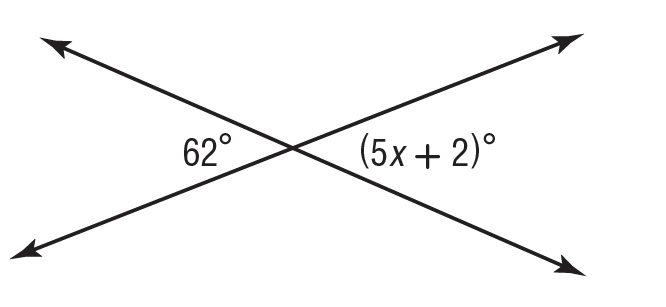Answer the mathemtical geometry problem and directly provide the correct option letter.
Question: What is the value of x in the figure?
Choices: A: 10 B: 12 C: 14 D: 15 B 